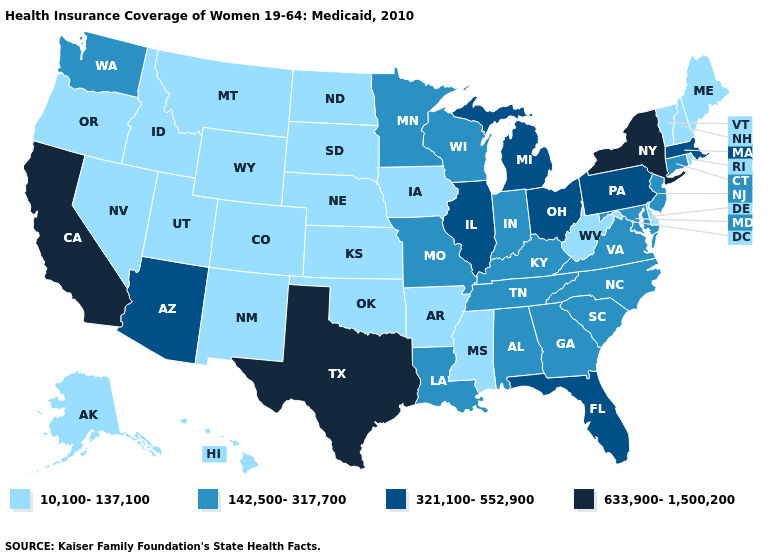What is the lowest value in the USA?
Quick response, please. 10,100-137,100. What is the lowest value in the USA?
Concise answer only. 10,100-137,100. Which states have the lowest value in the USA?
Be succinct. Alaska, Arkansas, Colorado, Delaware, Hawaii, Idaho, Iowa, Kansas, Maine, Mississippi, Montana, Nebraska, Nevada, New Hampshire, New Mexico, North Dakota, Oklahoma, Oregon, Rhode Island, South Dakota, Utah, Vermont, West Virginia, Wyoming. Name the states that have a value in the range 142,500-317,700?
Answer briefly. Alabama, Connecticut, Georgia, Indiana, Kentucky, Louisiana, Maryland, Minnesota, Missouri, New Jersey, North Carolina, South Carolina, Tennessee, Virginia, Washington, Wisconsin. What is the lowest value in states that border Pennsylvania?
Quick response, please. 10,100-137,100. Does New Mexico have a lower value than Minnesota?
Keep it brief. Yes. What is the value of Wyoming?
Answer briefly. 10,100-137,100. Which states have the highest value in the USA?
Short answer required. California, New York, Texas. Name the states that have a value in the range 321,100-552,900?
Answer briefly. Arizona, Florida, Illinois, Massachusetts, Michigan, Ohio, Pennsylvania. Does the map have missing data?
Write a very short answer. No. Does North Carolina have the lowest value in the USA?
Give a very brief answer. No. Does Texas have the same value as New York?
Write a very short answer. Yes. What is the lowest value in states that border New Mexico?
Write a very short answer. 10,100-137,100. Name the states that have a value in the range 10,100-137,100?
Be succinct. Alaska, Arkansas, Colorado, Delaware, Hawaii, Idaho, Iowa, Kansas, Maine, Mississippi, Montana, Nebraska, Nevada, New Hampshire, New Mexico, North Dakota, Oklahoma, Oregon, Rhode Island, South Dakota, Utah, Vermont, West Virginia, Wyoming. Does the first symbol in the legend represent the smallest category?
Write a very short answer. Yes. 